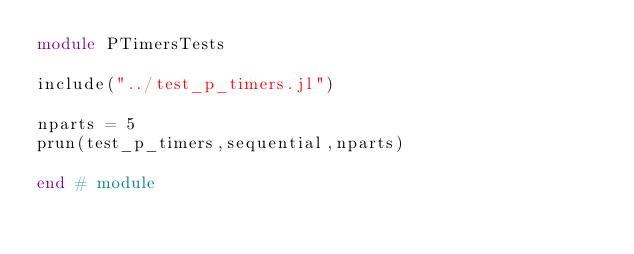Convert code to text. <code><loc_0><loc_0><loc_500><loc_500><_Julia_>module PTimersTests

include("../test_p_timers.jl")

nparts = 5
prun(test_p_timers,sequential,nparts)

end # module
</code> 